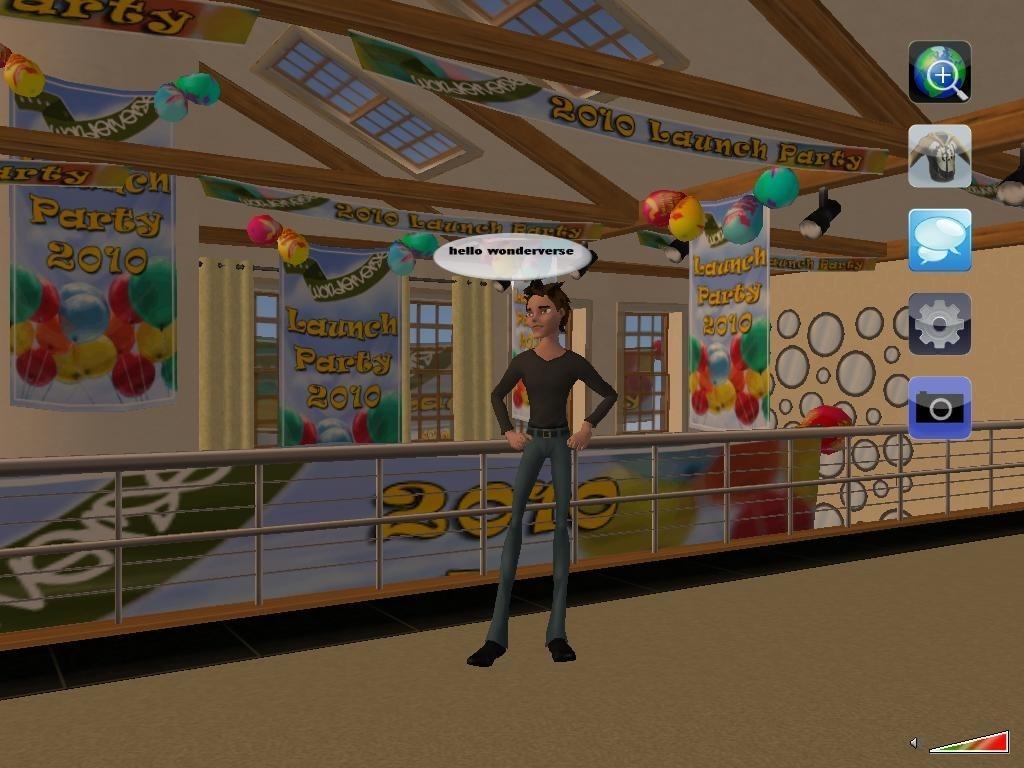How would you summarize this image in a sentence or two? In this picture I can see an animated image, on which we can see a person standing, side we can see a house to which we can see some banners and also we can see some applications on the screen. 